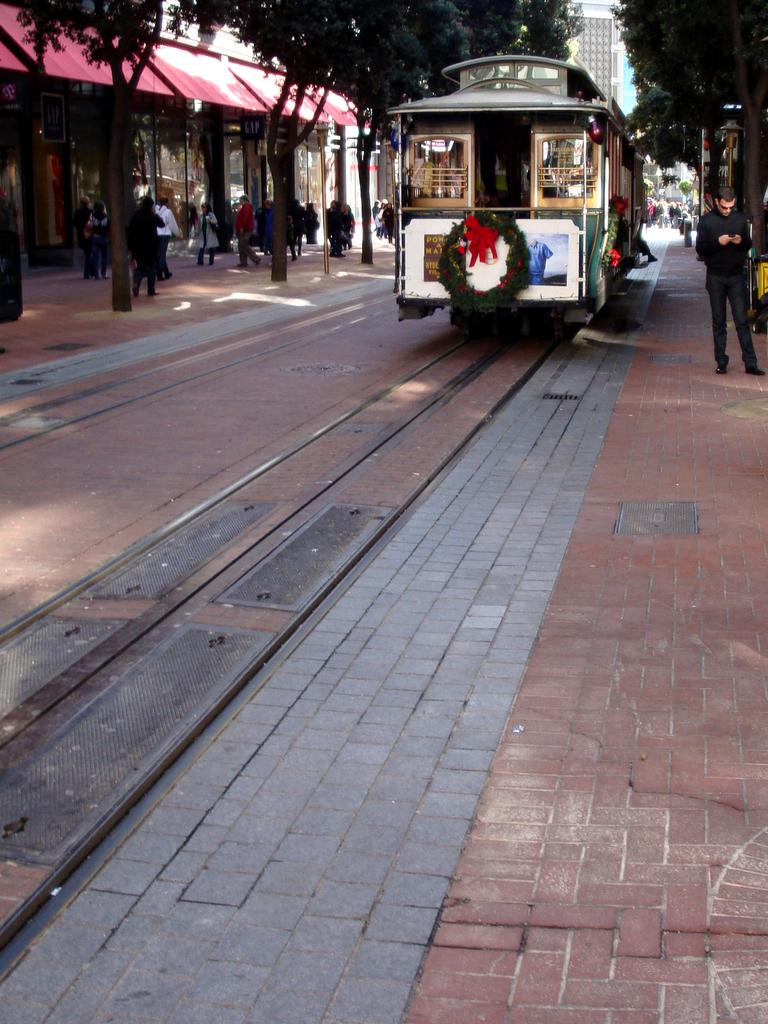What is the main subject of the image? The main subject of the image is a train. Where is the train located in the image? The train is on a railway track. What can be seen near the train in the image? There are people standing near the train. What is visible in the background of the image? There are trees and buildings in the background of the image. What type of pipe is being used by the business in the image? There is no pipe or business present in the image; it features a train on a railway track with people standing nearby and trees and buildings in the background. 